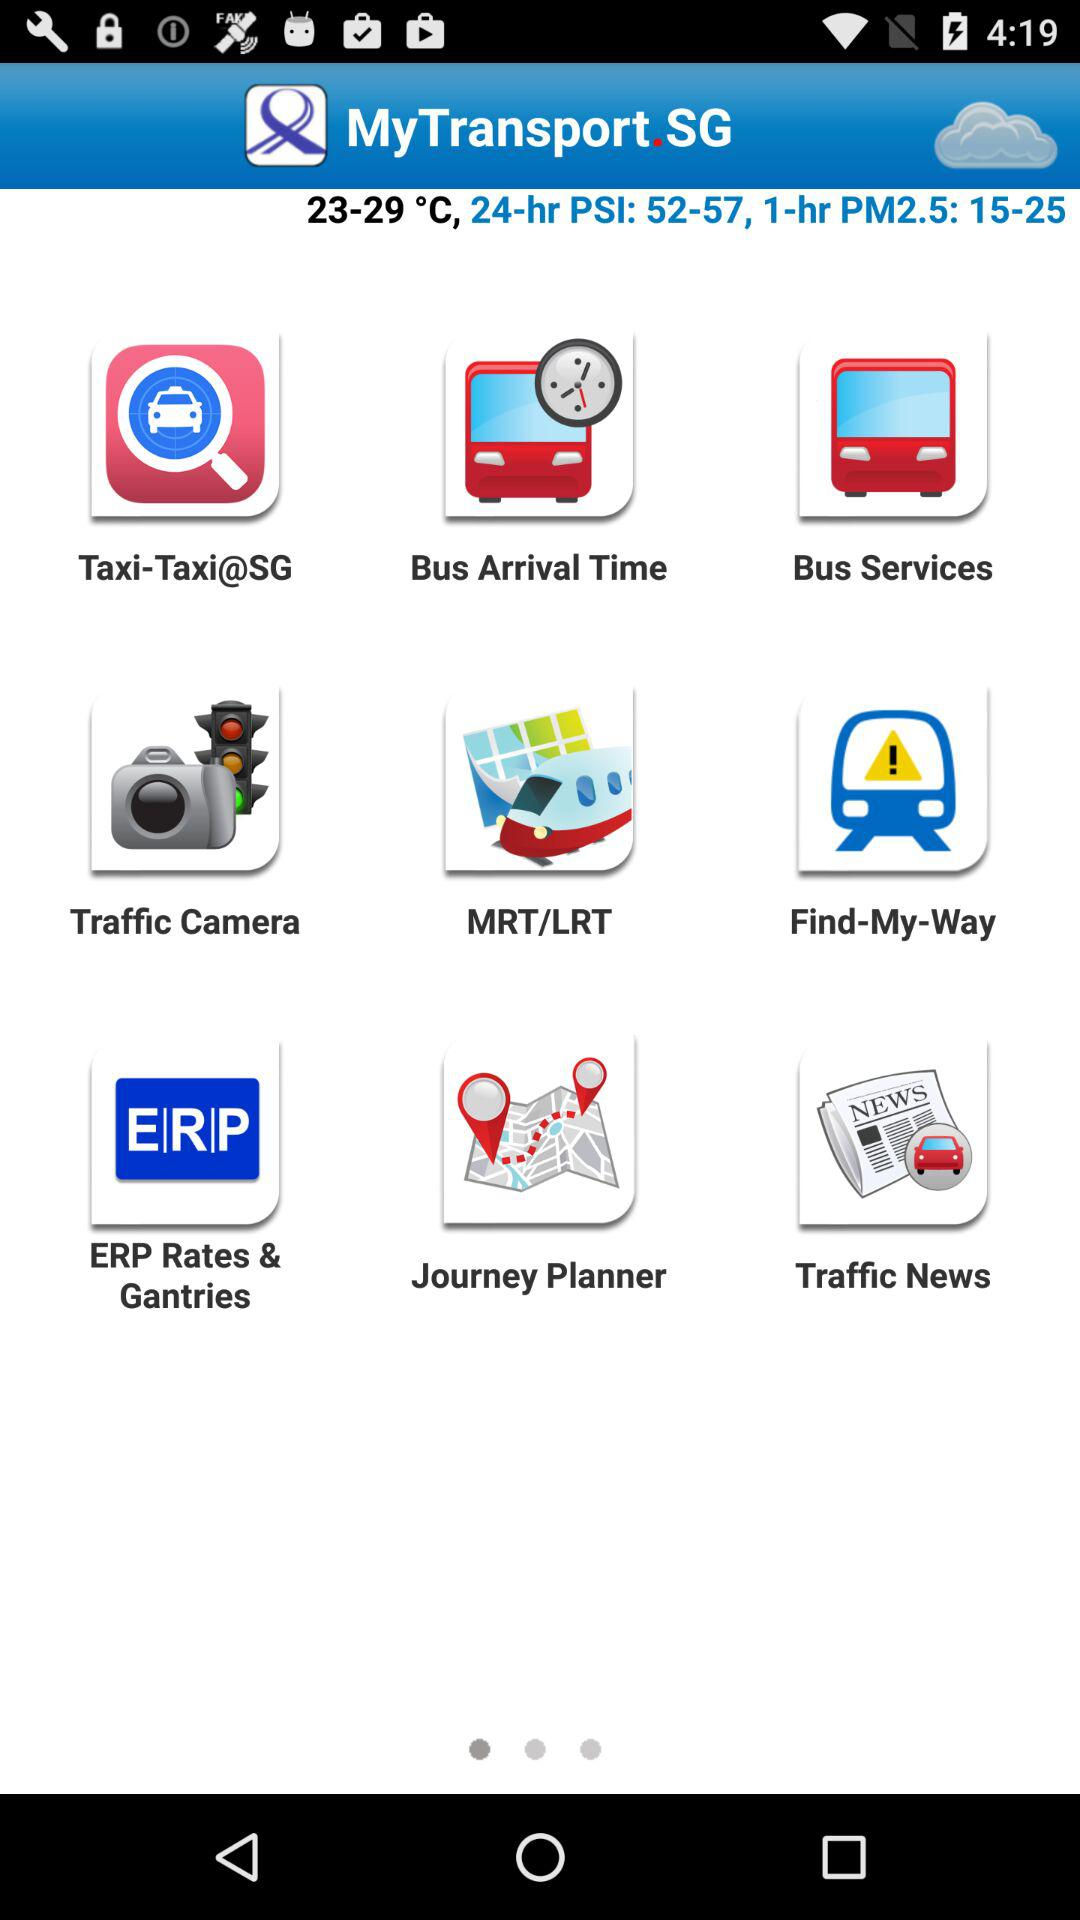What is the 1-hr PM2.5 reading? The 1-hour PM2.5 reading ranges from 15 to 25. 